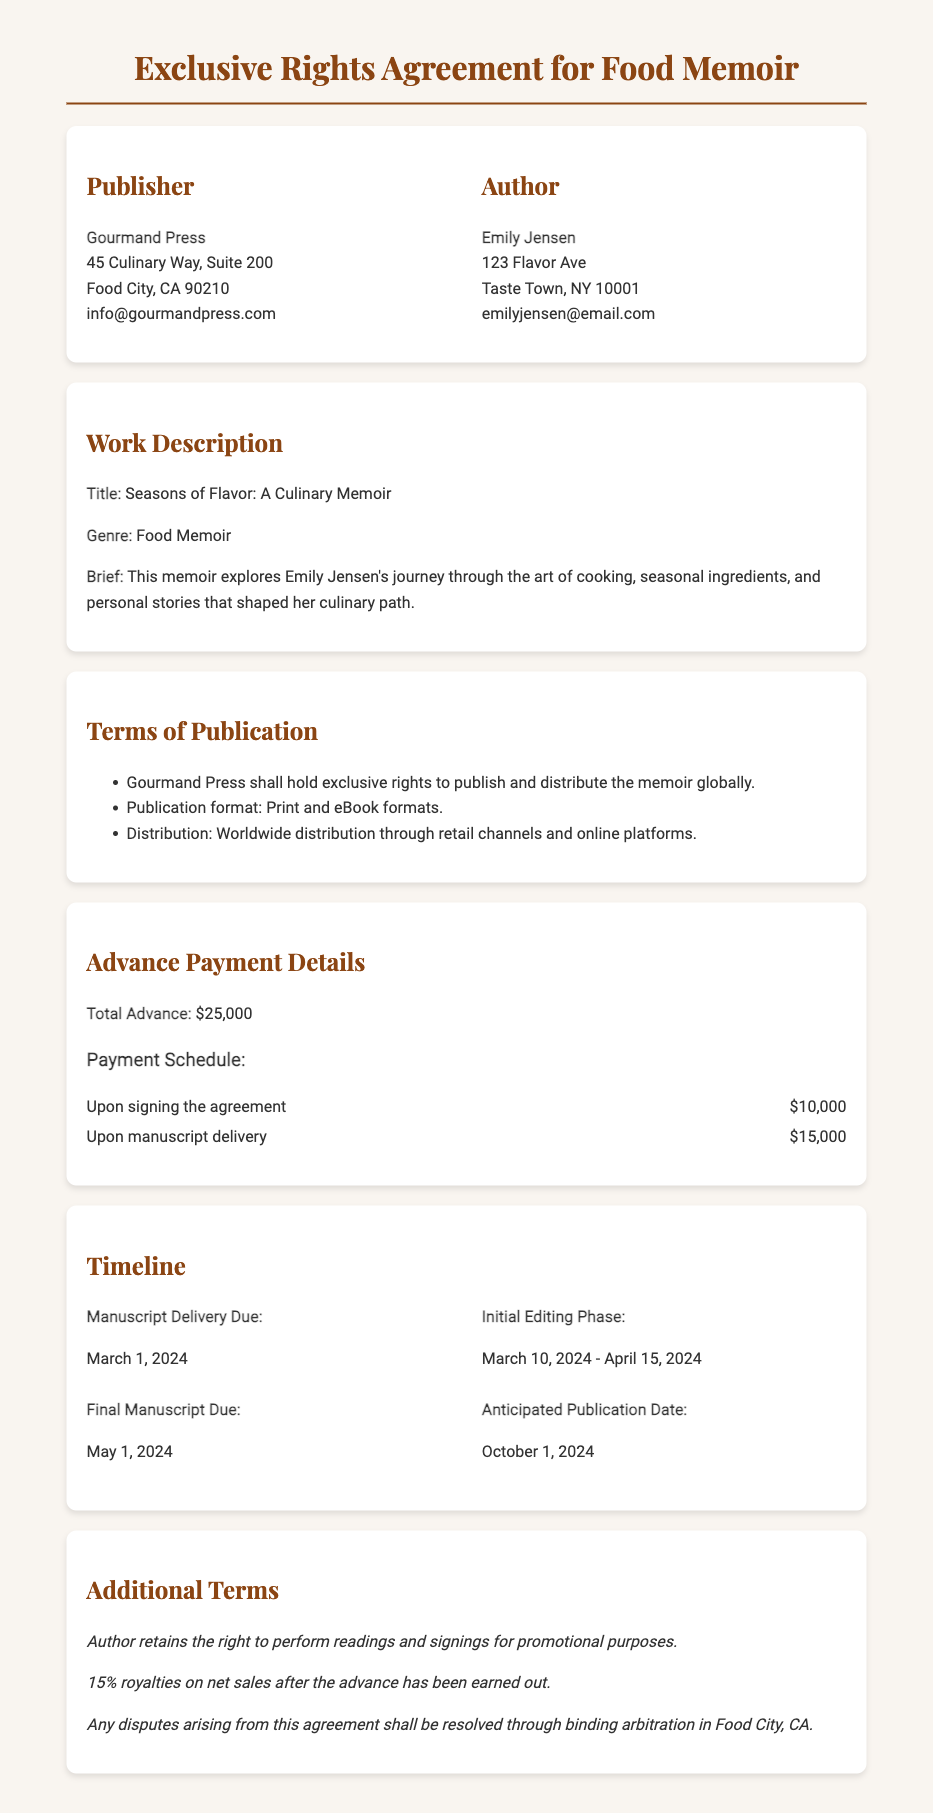What is the title of the memoir? The title of the memoir is explicitly stated in the document as "Seasons of Flavor: A Culinary Memoir."
Answer: Seasons of Flavor: A Culinary Memoir Who is the author of the memoir? The document names the author as "Emily Jensen."
Answer: Emily Jensen What is the total advance payment? The total advance payment detail is mentioned in the document as "$25,000."
Answer: $25,000 When is the manuscript delivery due? The specific date for manuscript delivery is given as "March 1, 2024."
Answer: March 1, 2024 How much is the first payment upon signing the agreement? The first payment amount upon signing the agreement is detailed as "$10,000."
Answer: $10,000 What percentage of royalties does the author retain? The document states the author retains "15% royalties on net sales."
Answer: 15% What is the anticipated publication date? The anticipated publication date is provided as "October 1, 2024."
Answer: October 1, 2024 During which dates will the initial editing phase occur? The editing phase is specified in the document as happening from "March 10, 2024 - April 15, 2024."
Answer: March 10, 2024 - April 15, 2024 What type of rights does Gourmand Press hold? The document indicates that Gourmand Press holds "exclusive rights to publish and distribute the memoir globally."
Answer: exclusive rights to publish and distribute the memoir globally 